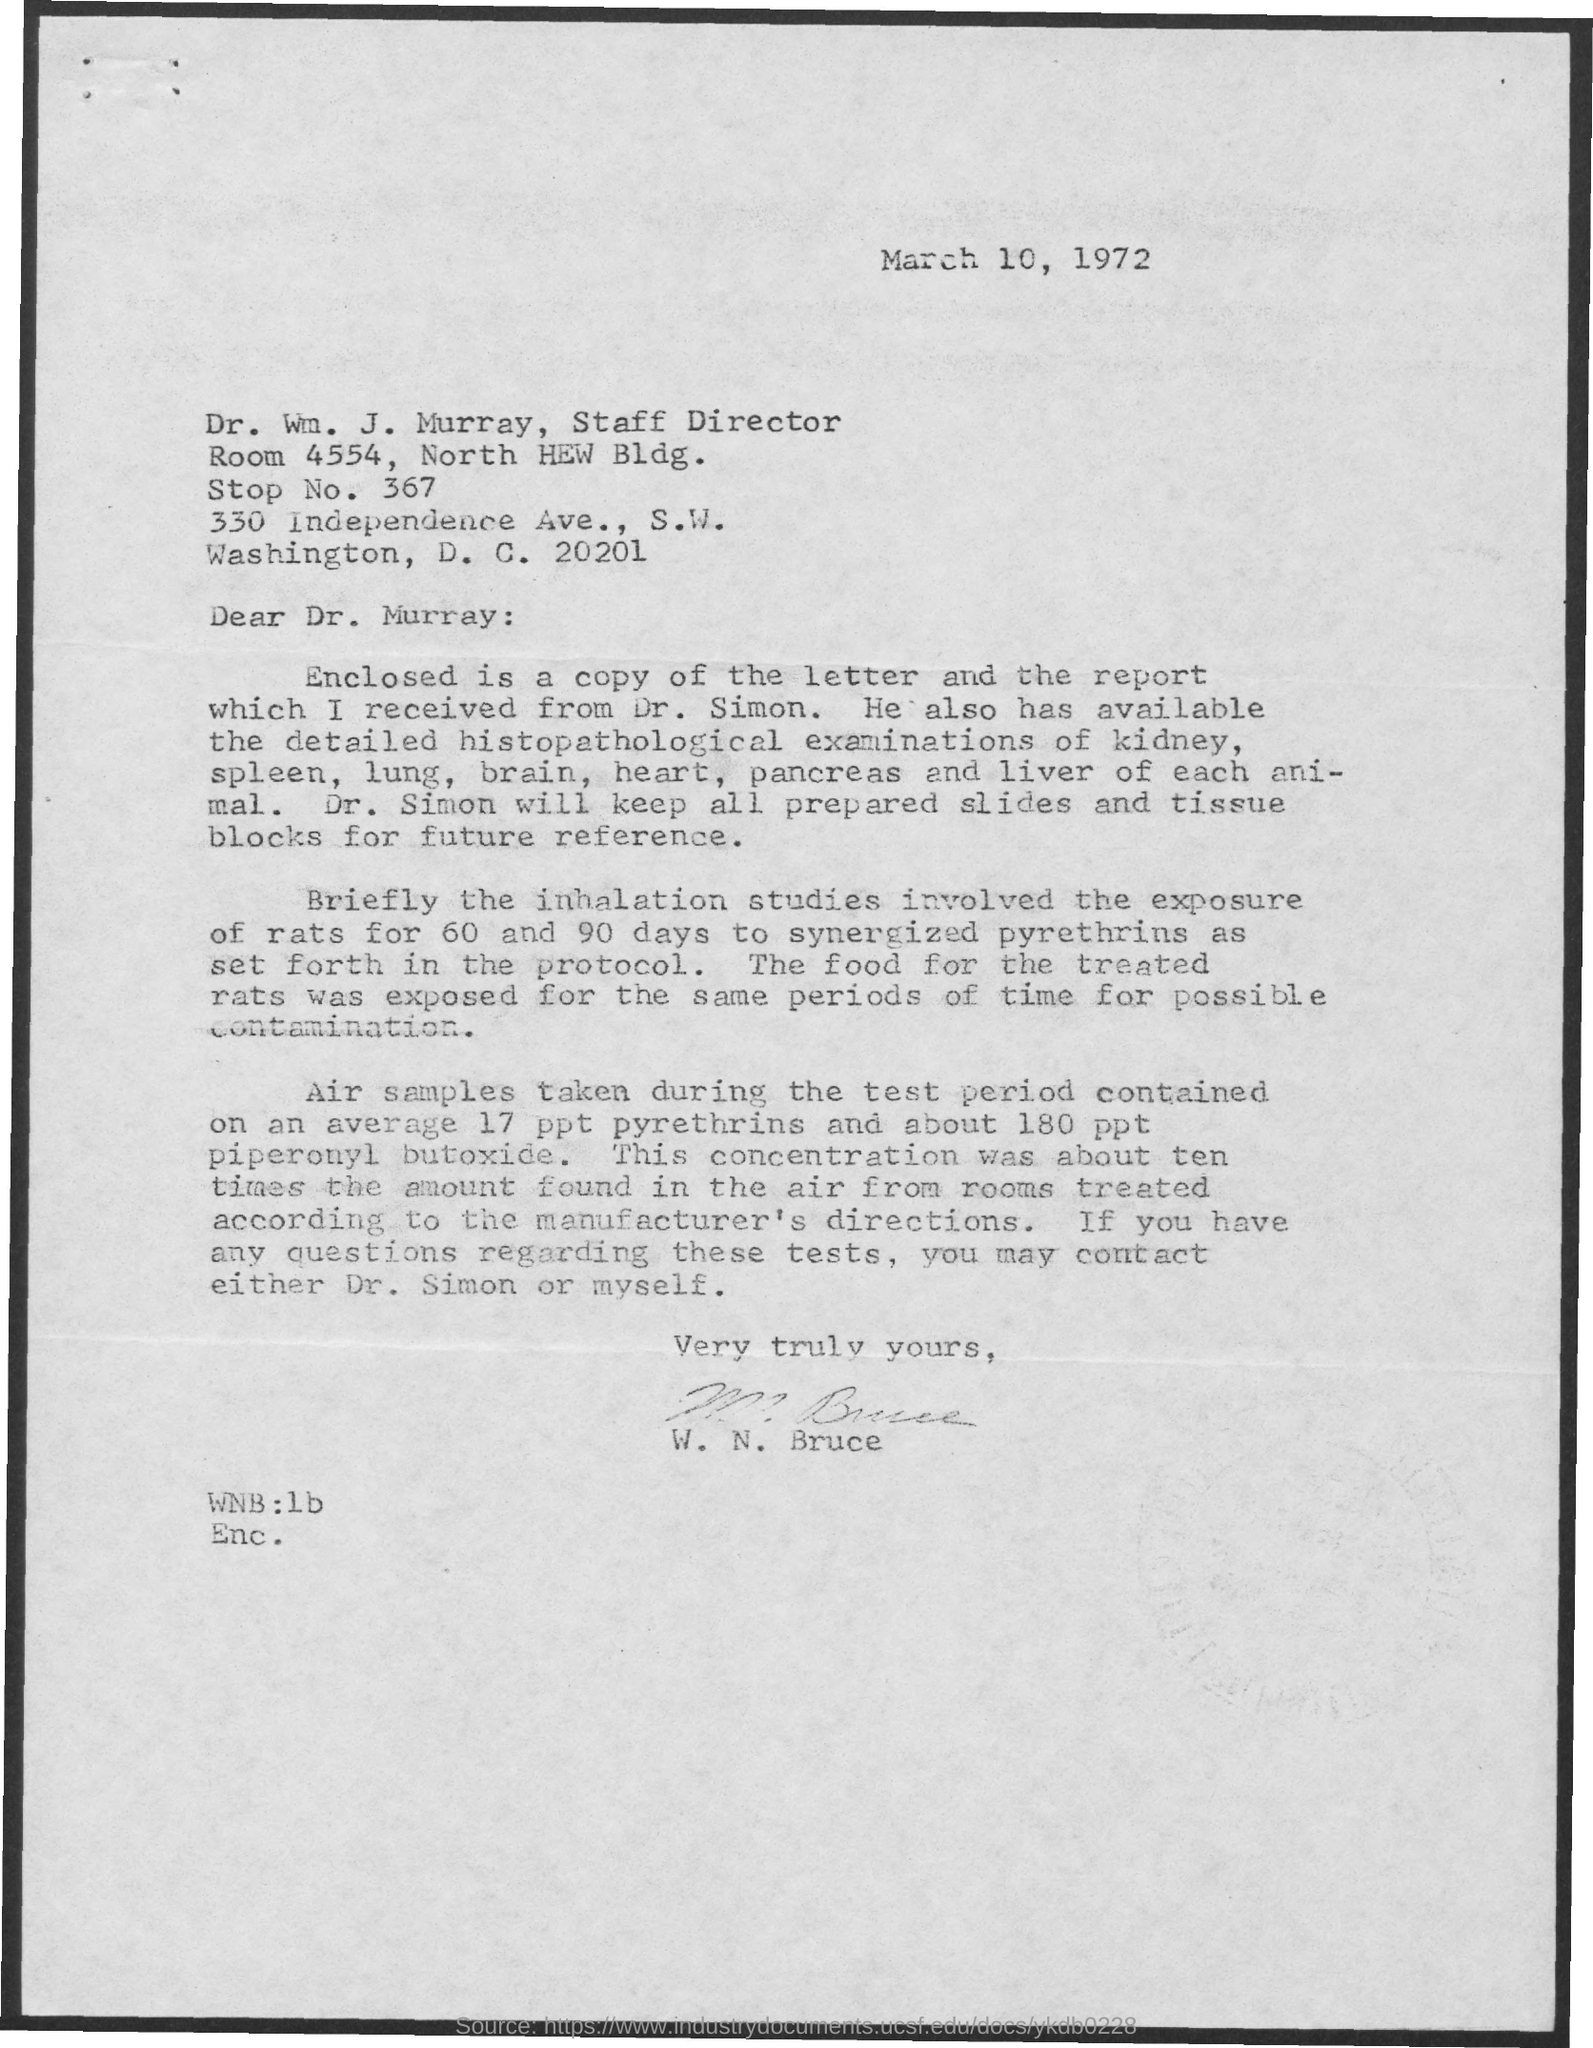Indicate a few pertinent items in this graphic. The date mentioned is March 10, 1972. What is stop no mentioned .? 367.." is a question asking about a specific stop and its corresponding number. 